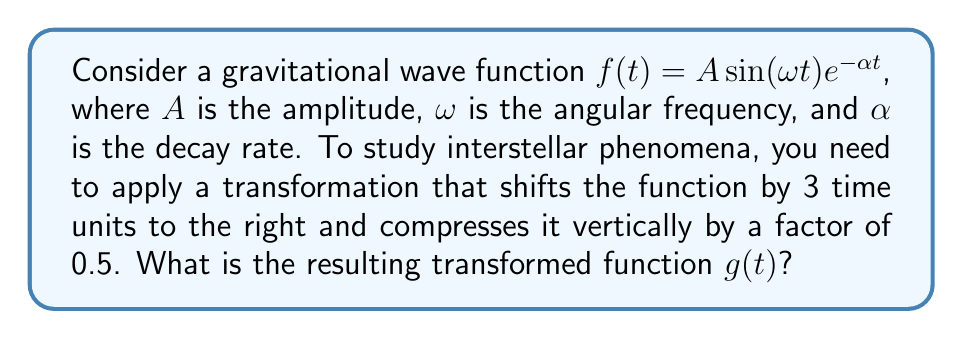Show me your answer to this math problem. To transform the given gravitational wave function, we'll follow these steps:

1. Start with the original function:
   $f(t) = A\sin(\omega t)e^{-\alpha t}$

2. Shift the function 3 units to the right:
   This transformation is represented as $t \rightarrow (t-3)$
   $f(t-3) = A\sin(\omega (t-3))e^{-\alpha (t-3)}$

3. Compress vertically by a factor of 0.5:
   This transformation is represented by multiplying the entire function by 0.5
   $g(t) = 0.5 \cdot f(t-3)$

4. Combine the transformations:
   $g(t) = 0.5 \cdot A\sin(\omega (t-3))e^{-\alpha (t-3)}$

5. Simplify:
   $g(t) = 0.5A\sin(\omega (t-3))e^{-\alpha (t-3)}$

   Note that we cannot further simplify the expression inside the sine function or the exponent, as $\omega$ and $\alpha$ are parameters that depend on the specific gravitational wave being studied.
Answer: $g(t) = 0.5A\sin(\omega (t-3))e^{-\alpha (t-3)}$ 